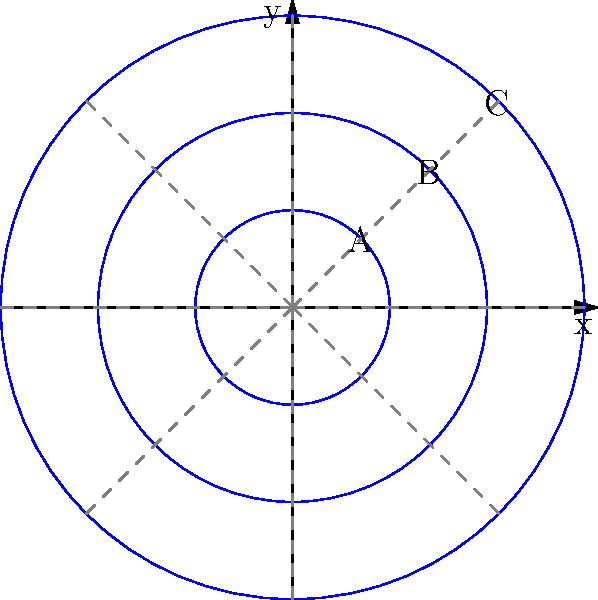In the comic panel above, concentric circular speech bubbles are used to represent different layers of dialogue. How does this visual arrangement relate to the concept of polar coordinates, and what literary effect might it achieve? To analyze this comic panel in terms of polar coordinates and its literary effect, let's follow these steps:

1. Polar coordinate system:
   - The concentric circles resemble the radial component ($r$) in polar coordinates.
   - The dashed lines radiating from the center represent the angular component ($\theta$).

2. Mapping to polar coordinates:
   - Each speech bubble can be described by its distance from the center ($r$) and its angular position ($\theta$).
   - For example, a point on bubble A might be represented as $(r_A, \theta)$, where $r_A$ is the radius of the innermost circle.

3. Literary interpretation:
   - The innermost bubble (A) might represent the character's immediate thoughts.
   - The middle bubble (B) could symbolize a secondary layer of consciousness.
   - The outermost bubble (C) might indicate background thoughts or external influences.

4. Narrative depth:
   - This arrangement allows for a visual representation of the character's multi-layered thought process.
   - Readers can "move" from the center outwards, experiencing different levels of the character's psyche.

5. Time and space in storytelling:
   - The radial distance ($r$) could represent the temporal aspect of thoughts.
   - The angular position ($\theta$) might indicate different topics or aspects of the character's mind.

6. Literary effect:
   - This structure creates a sense of depth and complexity in the character's inner monologue.
   - It allows for a non-linear reading experience, where readers can explore different layers of consciousness simultaneously.

By using this polar coordinate-like structure, the comic artist creates a visual metaphor for the complexity of human thought, allowing for a rich, multi-dimensional exploration of the character's psyche.
Answer: Visual metaphor for multi-layered consciousness using polar coordinate-like structure 